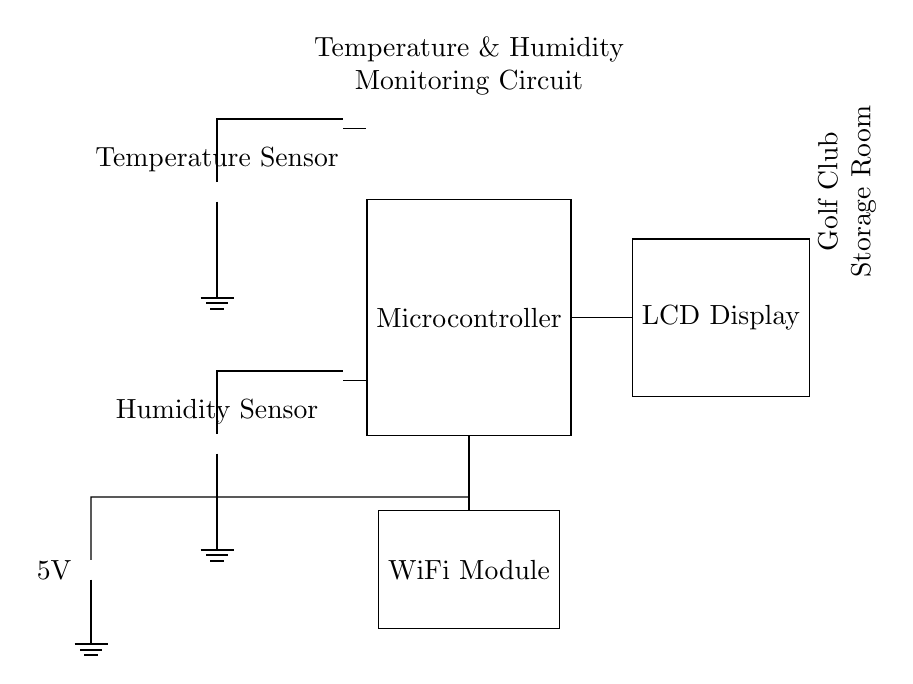What is the power supply voltage for this circuit? The power supply voltage is indicated as 5V. This is visible next to the battery component in the circuit diagram.
Answer: 5V What type of sensors are used in this circuit? The circuit includes a temperature sensor and a humidity sensor. These are labeled in the diagram showing their types clearly.
Answer: Temperature and humidity How is the microcontroller connected to the temperature sensor? The temperature sensor connects to the microcontroller through a direct wire that runs from the sensor to the microcontroller’s input side, specifically on the left side of the microcontroller.
Answer: Direct wire connection Which component is used to display the measurement results? The LCD Display is the component used to display the measurement results from the microcontroller. This is indicated by the label next to the rectangular component on the right.
Answer: LCD Display What is the purpose of the WiFi module in this circuit? The WiFi module provides wireless connectivity for sending or receiving data. This is inferred from its placement below the microcontroller, typically used in monitoring circuits for data communication.
Answer: Data communication How many primary components are involved in the monitoring circuit? The primary components include one temperature sensor, one humidity sensor, one microcontroller, one LCD display, one WiFi module, and one power supply. Adding these gives a total of six major components in the circuit.
Answer: Six components 